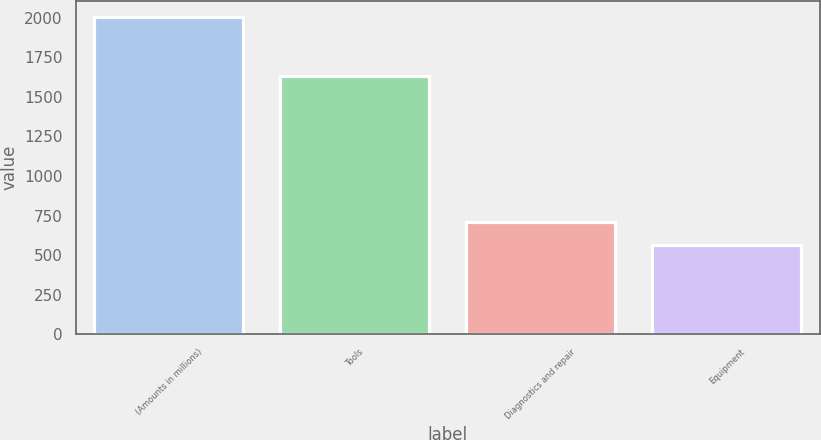<chart> <loc_0><loc_0><loc_500><loc_500><bar_chart><fcel>(Amounts in millions)<fcel>Tools<fcel>Diagnostics and repair<fcel>Equipment<nl><fcel>2007<fcel>1632.2<fcel>705.96<fcel>561.4<nl></chart> 